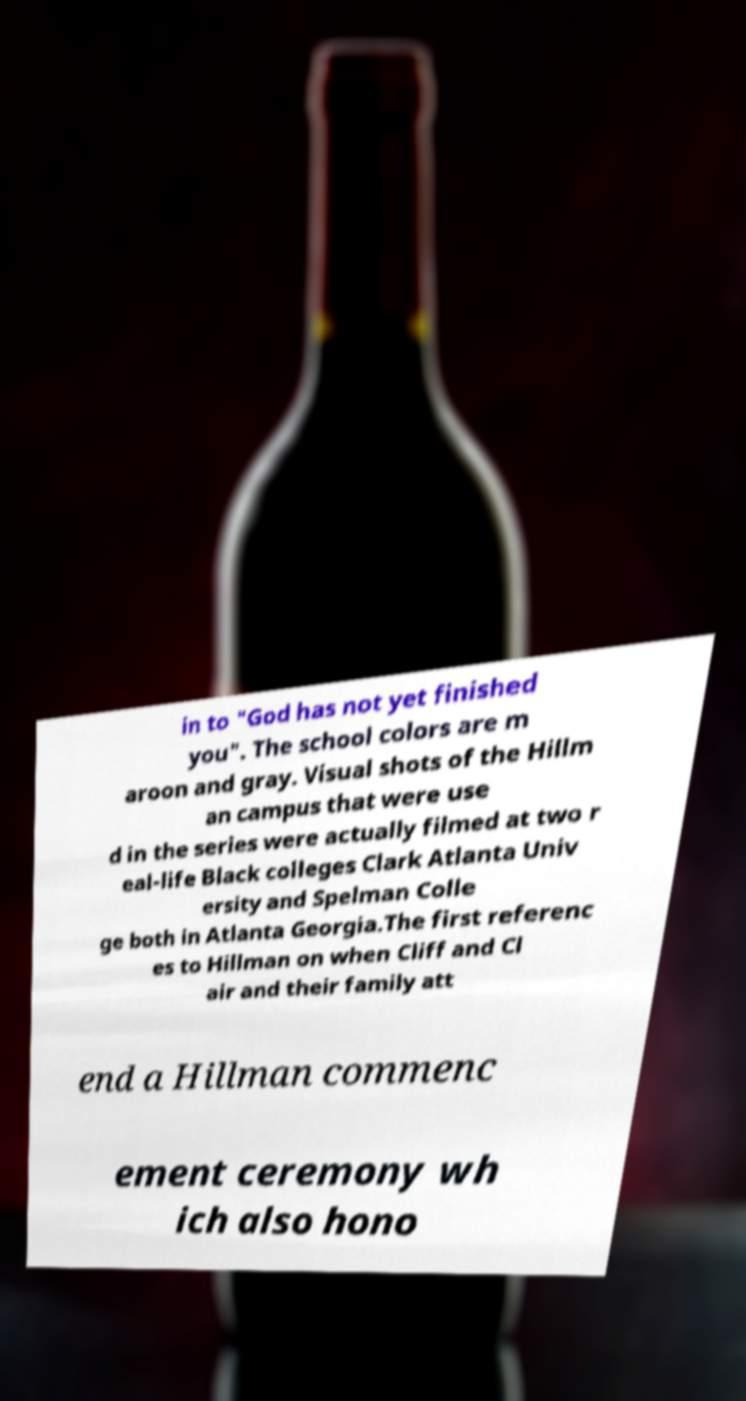Can you accurately transcribe the text from the provided image for me? in to "God has not yet finished you". The school colors are m aroon and gray. Visual shots of the Hillm an campus that were use d in the series were actually filmed at two r eal-life Black colleges Clark Atlanta Univ ersity and Spelman Colle ge both in Atlanta Georgia.The first referenc es to Hillman on when Cliff and Cl air and their family att end a Hillman commenc ement ceremony wh ich also hono 